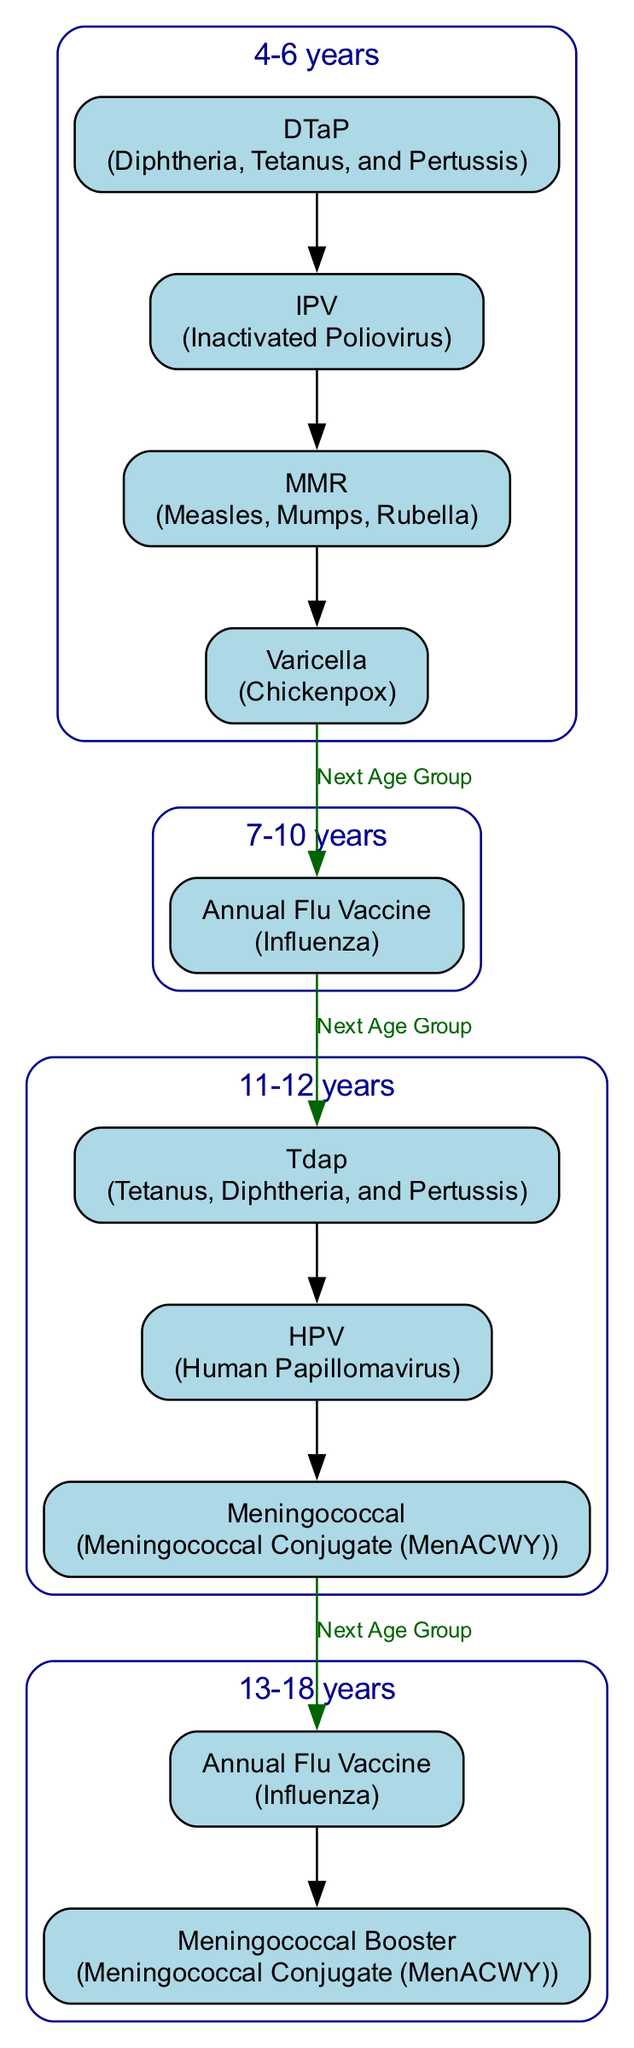What vaccinations are recommended for children aged 4-6 years? The diagram lists four vaccinations for this age group: DTaP, IPV, MMR, and Varicella.
Answer: DTaP, IPV, MMR, Varicella How many vaccinations are listed for the 11-12 years age group? The 11-12 years age group has three vaccinations listed: Tdap, HPV, and Meningococcal.
Answer: 3 What is the age range for receiving the Meningococcal Booster? The Meningococcal Booster is recommended for the age range of 13-18 years.
Answer: 13-18 years Which vaccination can be administered both at ages 7-10 and 13-18? The Annual Flu Vaccine is the vaccination administered in both age groups.
Answer: Annual Flu Vaccine What is the sequence of vaccinations for the age range of 11-12 years? The vaccinations for this age range are Tdap first, followed by HPV, and then Meningococcal, which indicates an order of administration.
Answer: Tdap, HPV, Meningococcal Which vaccination has a description involving "Chickenpox"? The Varicella vaccination is described as related to Chickenpox.
Answer: Varicella What vaccinations are given at 7-10 years of age? The only vaccination recommended for this age group is the Annual Flu Vaccine for Influenza.
Answer: Annual Flu Vaccine What do children aged 11-12 receive for Pertussis? Children aged 11-12 receive the Tdap vaccination for Pertussis.
Answer: Tdap 